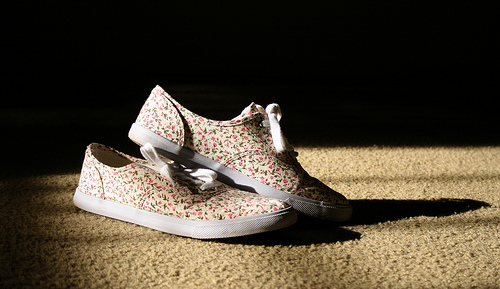<image>
Can you confirm if the shoe is on the carpet? Yes. Looking at the image, I can see the shoe is positioned on top of the carpet, with the carpet providing support. Is there a shoe on the shoe? No. The shoe is not positioned on the shoe. They may be near each other, but the shoe is not supported by or resting on top of the shoe. 